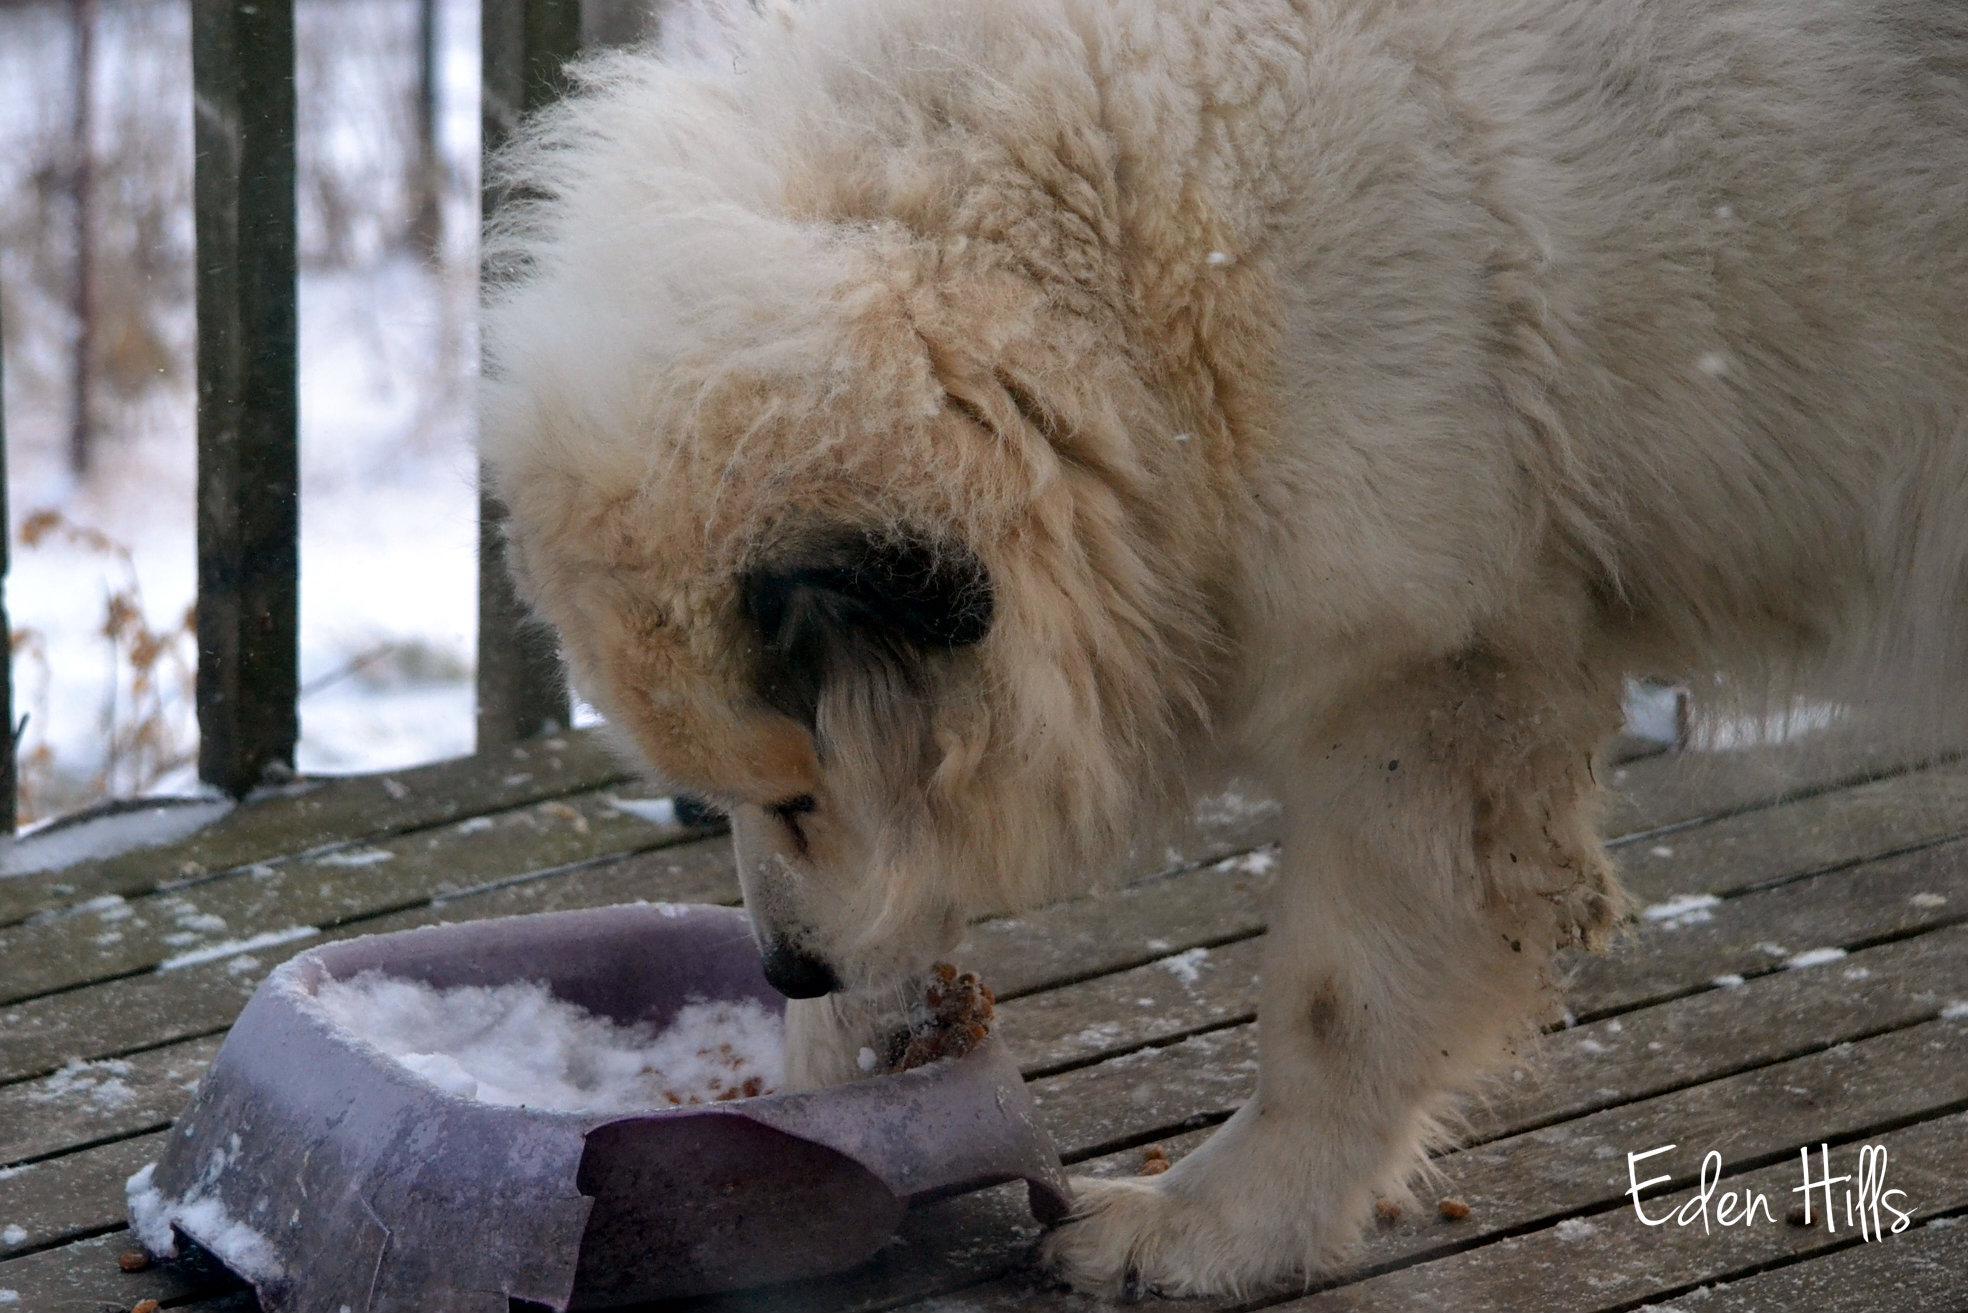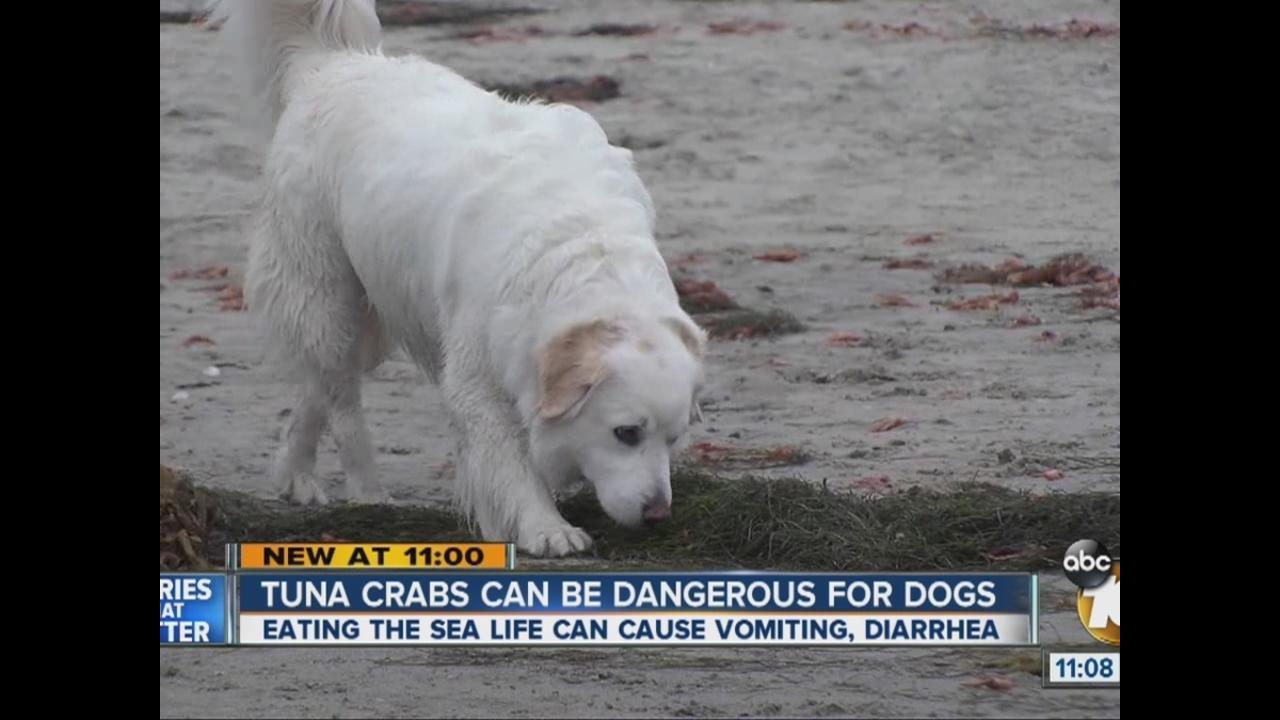The first image is the image on the left, the second image is the image on the right. Analyze the images presented: Is the assertion "At least four dogs are eating from bowls in the image on the left." valid? Answer yes or no. No. The first image is the image on the left, the second image is the image on the right. Considering the images on both sides, is "An image shows a dog standing in front of a chair with only his hind legs on the floor." valid? Answer yes or no. No. 